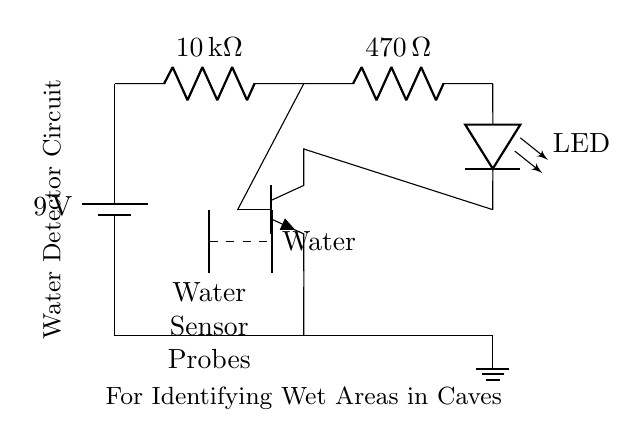What is the power supply voltage? The power supply voltage is shown next to the battery component. It indicates the electrical potential difference of the battery, which is noted as 9 volts in the circuit.
Answer: 9 volts What type of transistor is used in this circuit? The circuit diagram indicates an NPN transistor as it is referred to as "npn." This defines the type of silicon-based transistor that is being utilized in the circuit.
Answer: NPN How many resistors are present in the circuit? By counting the components within the circuit diagram, there are two resistors clearly labeled at specific positions in the circuit, one labeled ten thousand ohms and the other four hundred seventy ohms.
Answer: 2 What is the value of the first resistor? The first resistor is labeled in the circuit, showing its resistance value as ten thousand ohms, which is specified to clarify its role within the circuit.
Answer: 10 k ohms What component turns on when water is detected? The LED is the component that lights up when water is detected by the water sensor probes, as the circuit is designed to complete when moisture is present, triggering this visual indicator.
Answer: LED What do the dashed lines represent? The dashed lines in the circuit indicate the connection between the water sensor probes and the presence of water. This signifies that when water is detected between these probes, the circuit will be activated.
Answer: Water What is the function of the water sensor probes? The function of the water sensor probes is to detect moisture in the environment. When water makes contact between the two probes, it allows current to flow, enabling the circuit to light the LED as an alert.
Answer: To detect moisture 